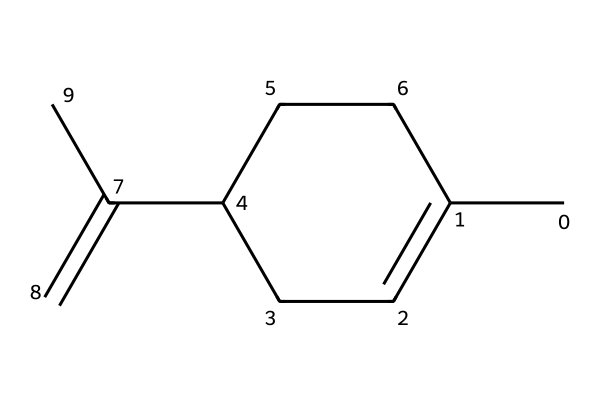What is the primary functional group present in this chemical? The structure contains a double bond between carbon atoms, which indicates the presence of an alkene functional group. This double bond is essential for defining the reactivity and properties of the compound.
Answer: alkene How many carbon atoms are present in this molecule? By counting the carbon atoms in the SMILES representation, there are seven carbon atoms in total. Each "C" in the SMILES corresponds to a carbon atom, and there are several indicated by the structure.
Answer: seven What is the molecular formula of this chemical? To derive the molecular formula, we identify the number of each type of atom: there are 7 carbons and 12 hydrogens, giving us the formula C7H12. This information is derived from the visual structure as it indicates the number of hydrogen atoms bonded to each carbon.
Answer: C7H12 Does the structure suggest that this chemical is a solid, liquid, or gas at room temperature? The structure includes carbon and hydrogen in an unsaturated (alkene) formation, suggesting it is likely to be a liquid at room temperature, as most small hydrocarbons with similar structures tend to be liquid. The structure is not bulky or branched enough to suggest a solid.
Answer: liquid What role might this chemical play in air fresheners? The presence of the alkene functionality suggests that it could act as a fragrance component in air fresheners, which often use such compounds for their pleasant scents. The structure indicates it can evaporate easily, making it suitable for use.
Answer: fragrance How many hydrogen atoms are directly bonded to carbon in this molecule? In the structure, each carbon can bond to additional hydrogen atoms to satisfy the tetravalency of carbon. There are a total of 12 hydrogen atoms represented in the structure derived from the bonding arrangement of the carbons.
Answer: twelve 